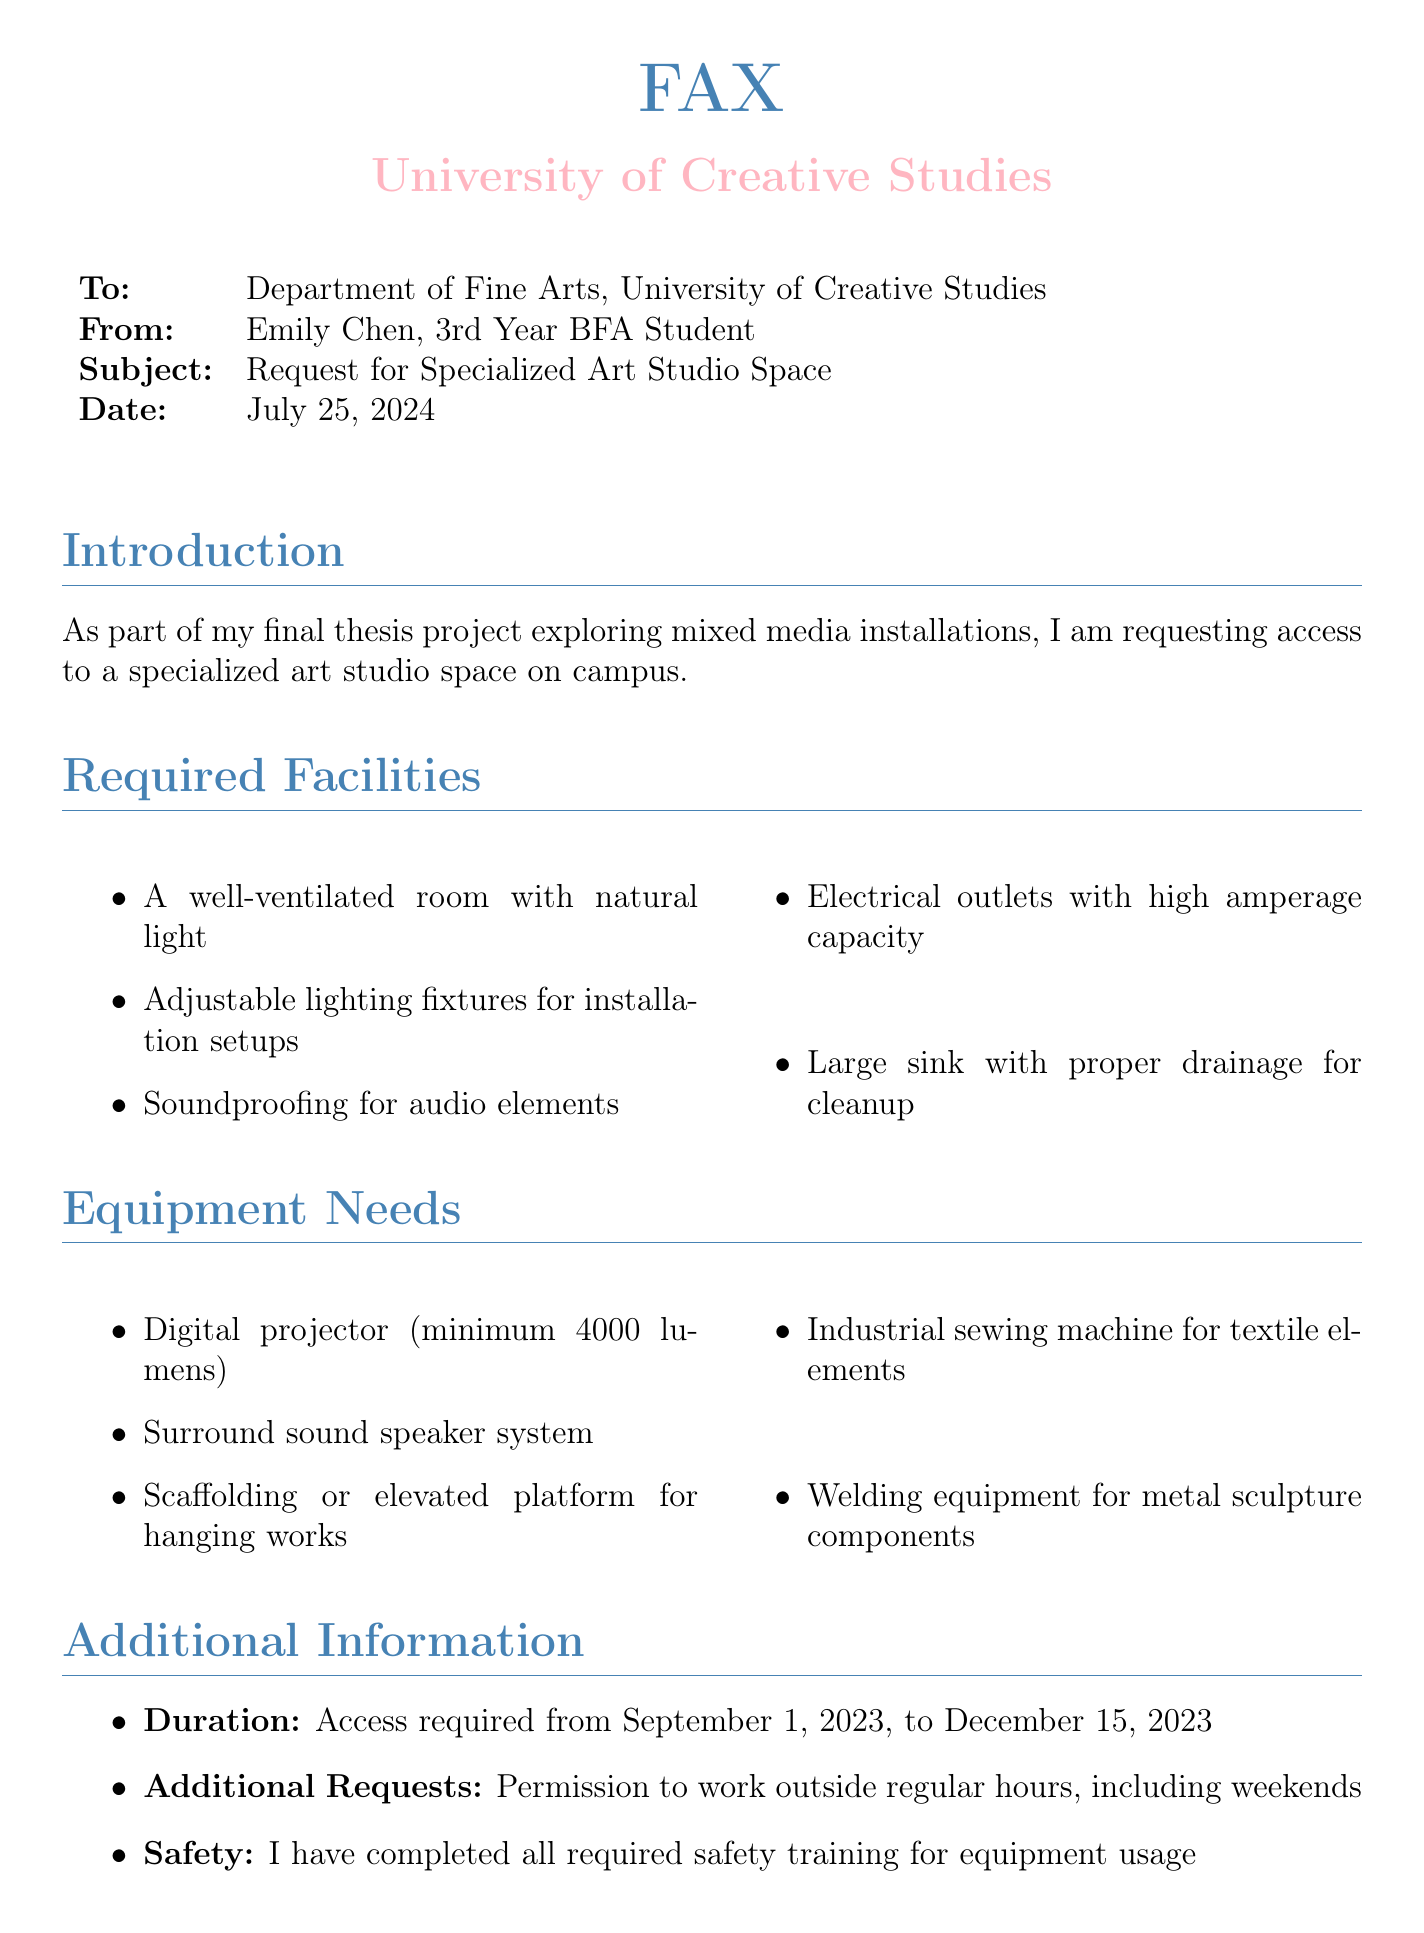what is the name of the sender? The sender's name is provided in the document as Emily Chen.
Answer: Emily Chen what is the date of the fax? The date is listed as today's date in the document, which will be automatically filled in.
Answer: today what is the duration of access requested? The duration of access is mentioned in the document, specifying the start and end dates.
Answer: September 1, 2023, to December 15, 2023 what type of equipment is needed for audio elements? The document specifies the kind of equipment needed for audio elements in the installations.
Answer: Surround sound speaker system how many lighting types are specifically mentioned? The document lists lighting requirements, indicating how many specific types are mentioned.
Answer: Two what specific training has been completed by the sender? The document states that the sender has completed required safety training.
Answer: Safety training which department is the fax directed to? The recipient department is clearly mentioned at the beginning of the document.
Answer: Department of Fine Arts what specialized studio space is being requested? The document indicates the purpose of the request for the specialized space in terms of the sender's project.
Answer: Specialized art studio space what is the primary focus of the thesis project? The focus of the thesis project is outlined in the introduction of the document.
Answer: Mixed media installations 